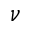<formula> <loc_0><loc_0><loc_500><loc_500>\nu</formula> 